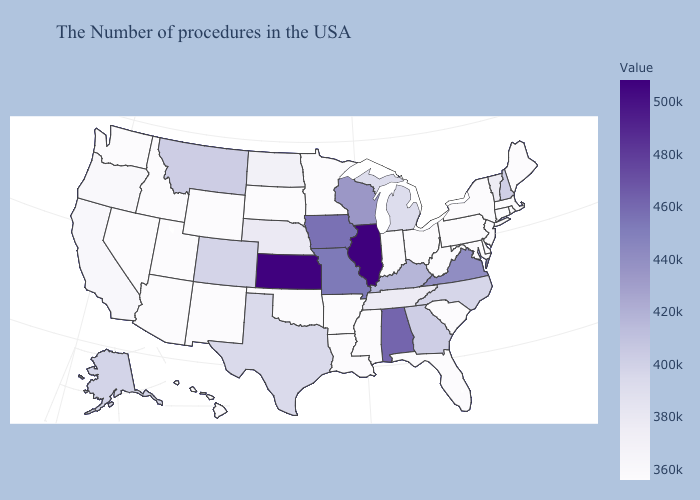Which states have the lowest value in the Northeast?
Quick response, please. Maine, Massachusetts, Rhode Island, Connecticut, New York, New Jersey, Pennsylvania. Does Illinois have the highest value in the USA?
Write a very short answer. Yes. Does Minnesota have the lowest value in the MidWest?
Keep it brief. Yes. Which states have the lowest value in the West?
Give a very brief answer. Wyoming, New Mexico, Utah, Arizona, Idaho, Nevada, Washington, Hawaii. 